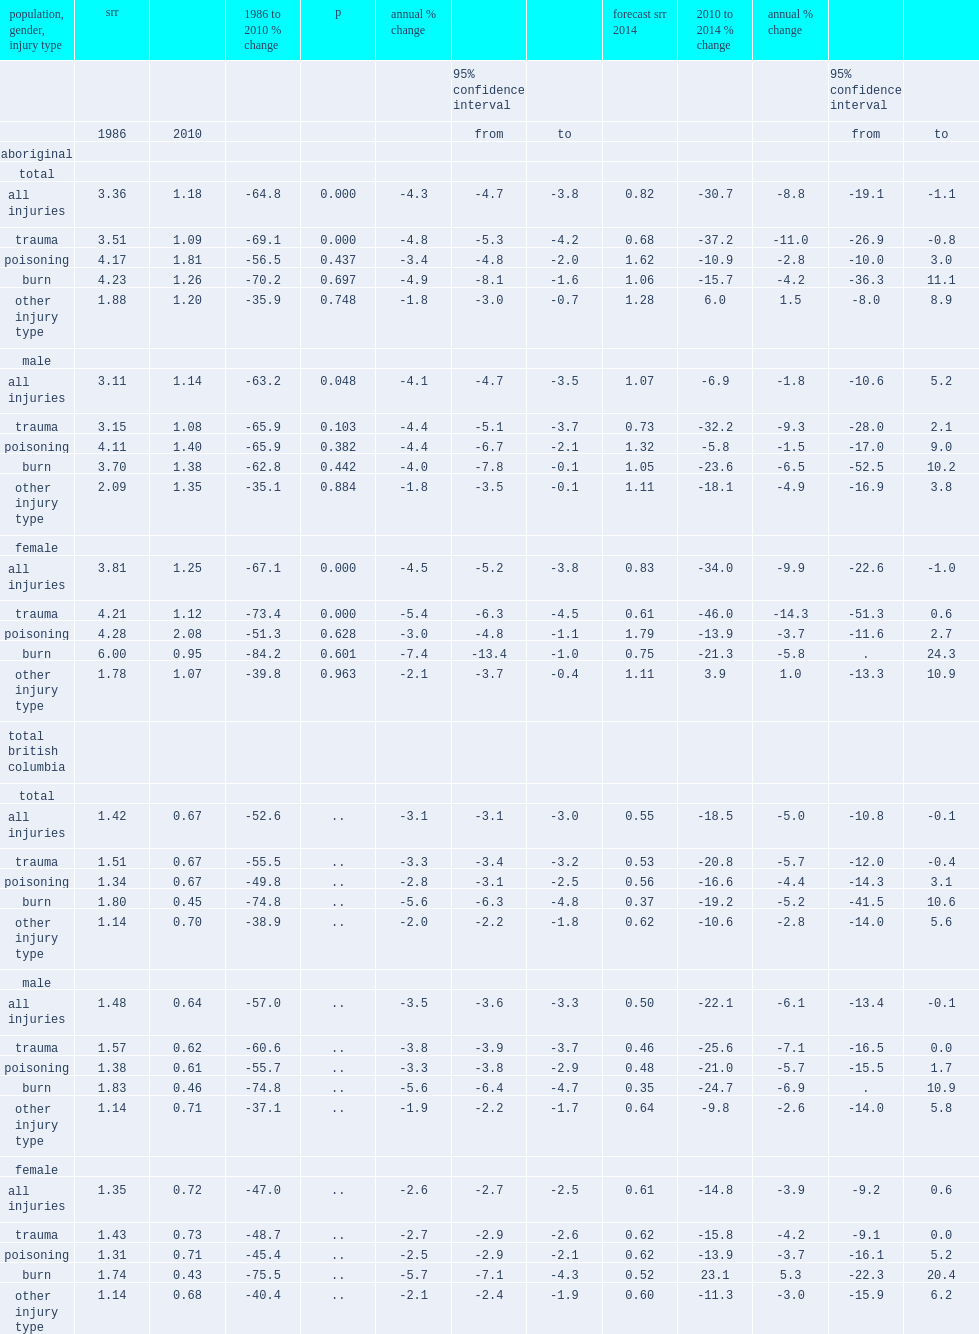What was the percent change of the srr of hospitalization for all injury types from 1986 to 2010 ? -64.8. What was the percent change of the srr of hospitalization for all injury types among aboriginal males from 1986 to 2010 ? -63.2. What was the percent change of the srr of hospitalization for all injury types among aboriginal females from 1986 to 2010 ? -67.1. What was the percent change of the srr of hospitalization for trauma among aboriginal population from 1986 to 2010? -69.1. What were the percent changes of the srr of hospitalization for trauma among aboriginal males and british columbia males? -65.9 -60.6. What were the percent changes of the srr of hospitalization for trauma among aboriginal females and british columbia females? -73.4 -48.7. 